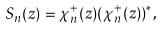<formula> <loc_0><loc_0><loc_500><loc_500>S _ { n } ( z ) = \chi _ { n } ^ { + } ( z ) ( \chi _ { n } ^ { + } ( z ) ) ^ { * } ,</formula> 